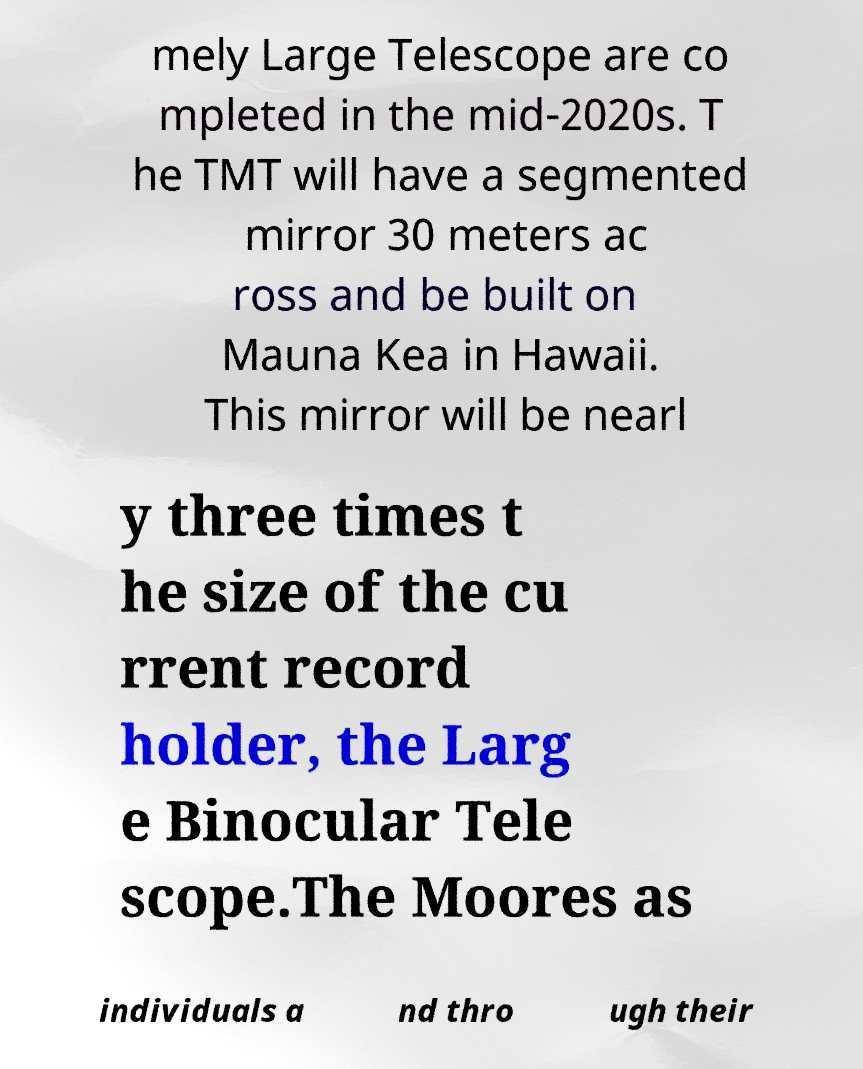Could you assist in decoding the text presented in this image and type it out clearly? mely Large Telescope are co mpleted in the mid-2020s. T he TMT will have a segmented mirror 30 meters ac ross and be built on Mauna Kea in Hawaii. This mirror will be nearl y three times t he size of the cu rrent record holder, the Larg e Binocular Tele scope.The Moores as individuals a nd thro ugh their 